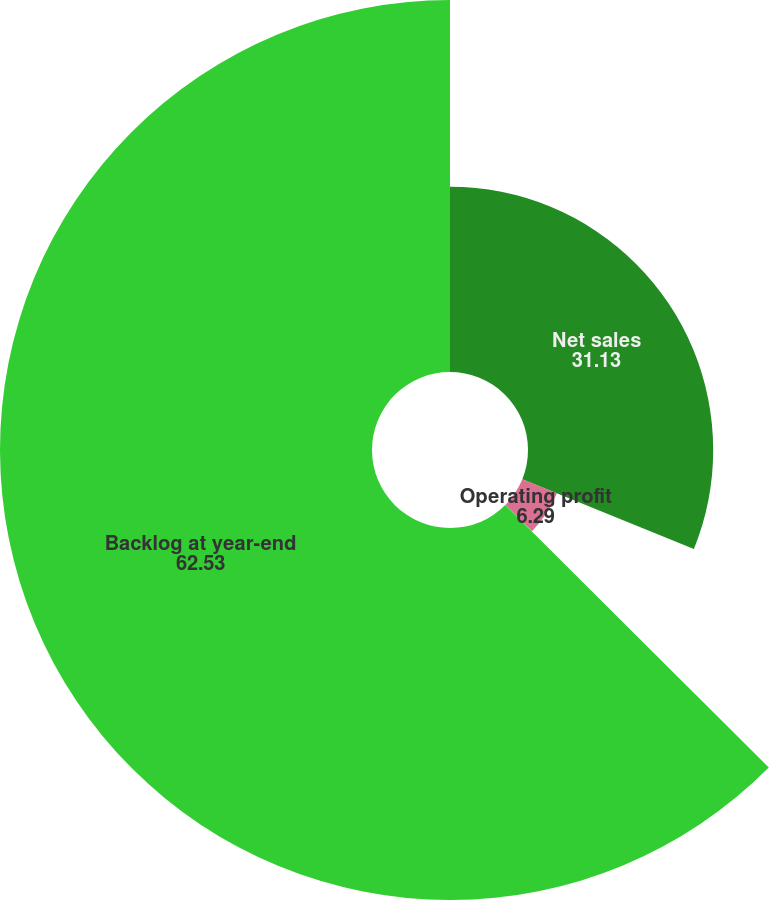Convert chart to OTSL. <chart><loc_0><loc_0><loc_500><loc_500><pie_chart><fcel>Net sales<fcel>Operating profit<fcel>Operating margin<fcel>Backlog at year-end<nl><fcel>31.13%<fcel>6.29%<fcel>0.05%<fcel>62.53%<nl></chart> 